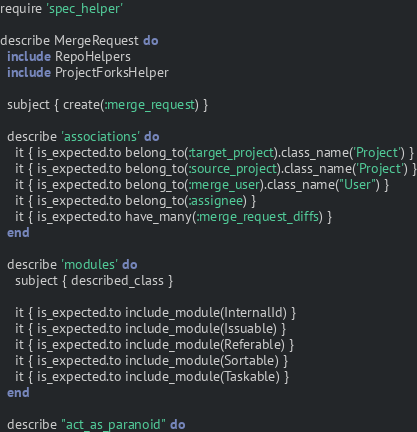<code> <loc_0><loc_0><loc_500><loc_500><_Ruby_>require 'spec_helper'

describe MergeRequest do
  include RepoHelpers
  include ProjectForksHelper

  subject { create(:merge_request) }

  describe 'associations' do
    it { is_expected.to belong_to(:target_project).class_name('Project') }
    it { is_expected.to belong_to(:source_project).class_name('Project') }
    it { is_expected.to belong_to(:merge_user).class_name("User") }
    it { is_expected.to belong_to(:assignee) }
    it { is_expected.to have_many(:merge_request_diffs) }
  end

  describe 'modules' do
    subject { described_class }

    it { is_expected.to include_module(InternalId) }
    it { is_expected.to include_module(Issuable) }
    it { is_expected.to include_module(Referable) }
    it { is_expected.to include_module(Sortable) }
    it { is_expected.to include_module(Taskable) }
  end

  describe "act_as_paranoid" do</code> 